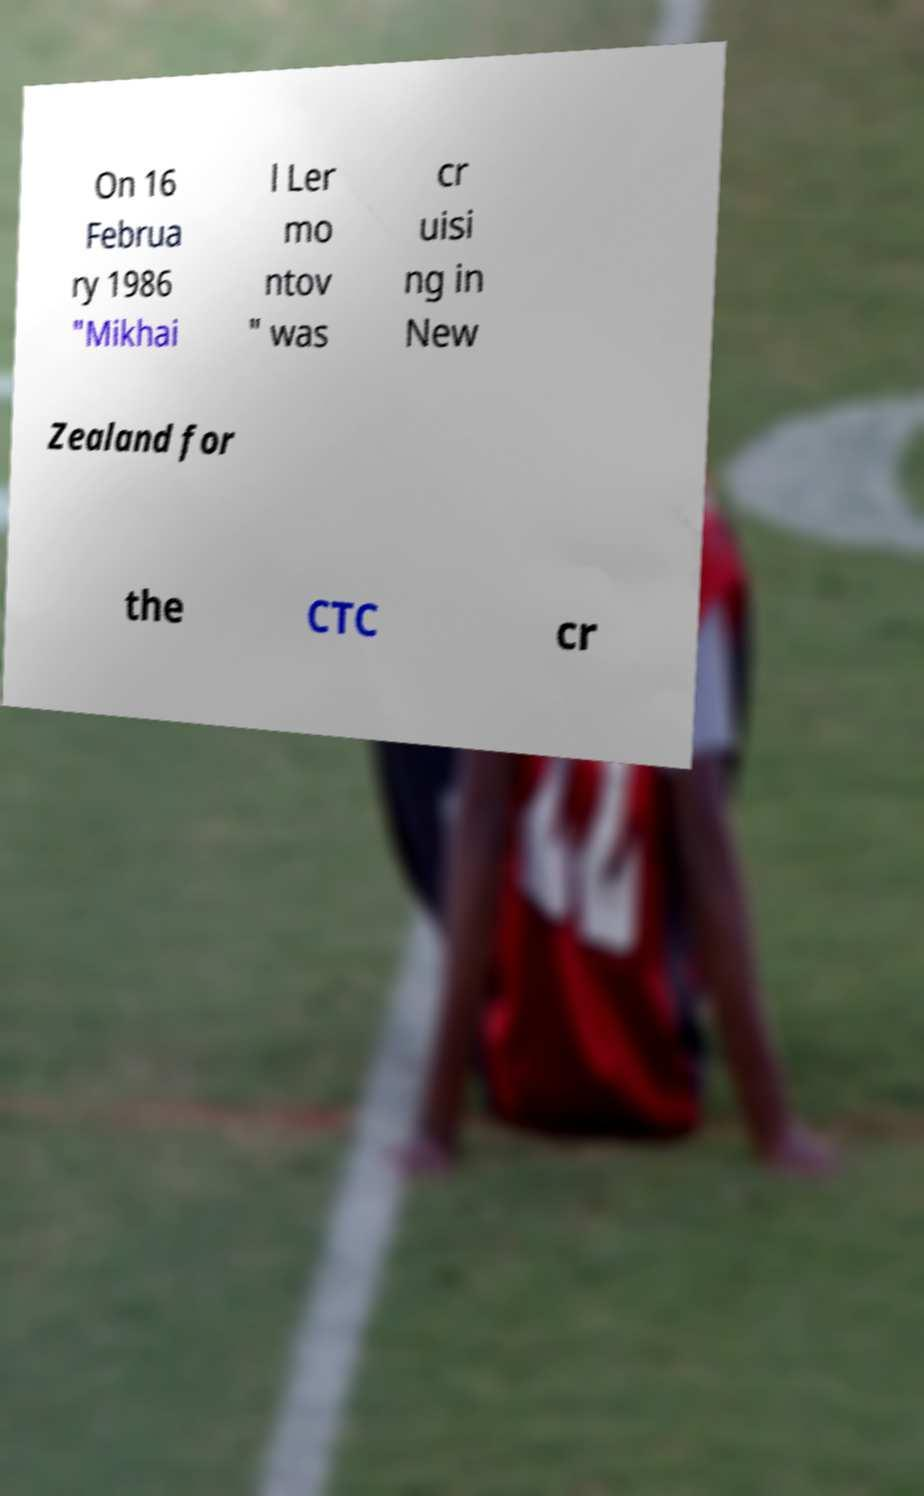What messages or text are displayed in this image? I need them in a readable, typed format. On 16 Februa ry 1986 "Mikhai l Ler mo ntov " was cr uisi ng in New Zealand for the CTC cr 